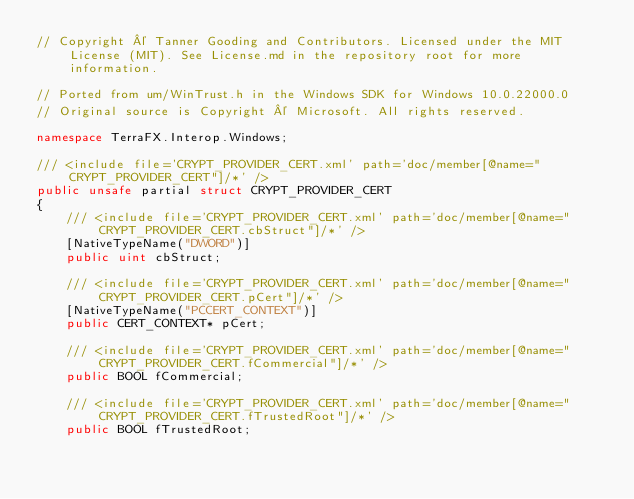Convert code to text. <code><loc_0><loc_0><loc_500><loc_500><_C#_>// Copyright © Tanner Gooding and Contributors. Licensed under the MIT License (MIT). See License.md in the repository root for more information.

// Ported from um/WinTrust.h in the Windows SDK for Windows 10.0.22000.0
// Original source is Copyright © Microsoft. All rights reserved.

namespace TerraFX.Interop.Windows;

/// <include file='CRYPT_PROVIDER_CERT.xml' path='doc/member[@name="CRYPT_PROVIDER_CERT"]/*' />
public unsafe partial struct CRYPT_PROVIDER_CERT
{
    /// <include file='CRYPT_PROVIDER_CERT.xml' path='doc/member[@name="CRYPT_PROVIDER_CERT.cbStruct"]/*' />
    [NativeTypeName("DWORD")]
    public uint cbStruct;

    /// <include file='CRYPT_PROVIDER_CERT.xml' path='doc/member[@name="CRYPT_PROVIDER_CERT.pCert"]/*' />
    [NativeTypeName("PCCERT_CONTEXT")]
    public CERT_CONTEXT* pCert;

    /// <include file='CRYPT_PROVIDER_CERT.xml' path='doc/member[@name="CRYPT_PROVIDER_CERT.fCommercial"]/*' />
    public BOOL fCommercial;

    /// <include file='CRYPT_PROVIDER_CERT.xml' path='doc/member[@name="CRYPT_PROVIDER_CERT.fTrustedRoot"]/*' />
    public BOOL fTrustedRoot;
</code> 